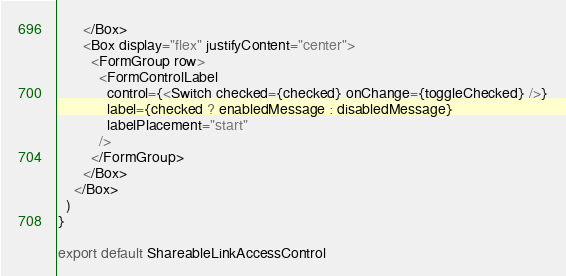Convert code to text. <code><loc_0><loc_0><loc_500><loc_500><_JavaScript_>      </Box>
      <Box display="flex" justifyContent="center">
        <FormGroup row>
          <FormControlLabel
            control={<Switch checked={checked} onChange={toggleChecked} />}
            label={checked ? enabledMessage : disabledMessage}
            labelPlacement="start"
          />
        </FormGroup>
      </Box>
    </Box>
  )
}

export default ShareableLinkAccessControl
</code> 